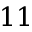Convert formula to latex. <formula><loc_0><loc_0><loc_500><loc_500>1 1</formula> 